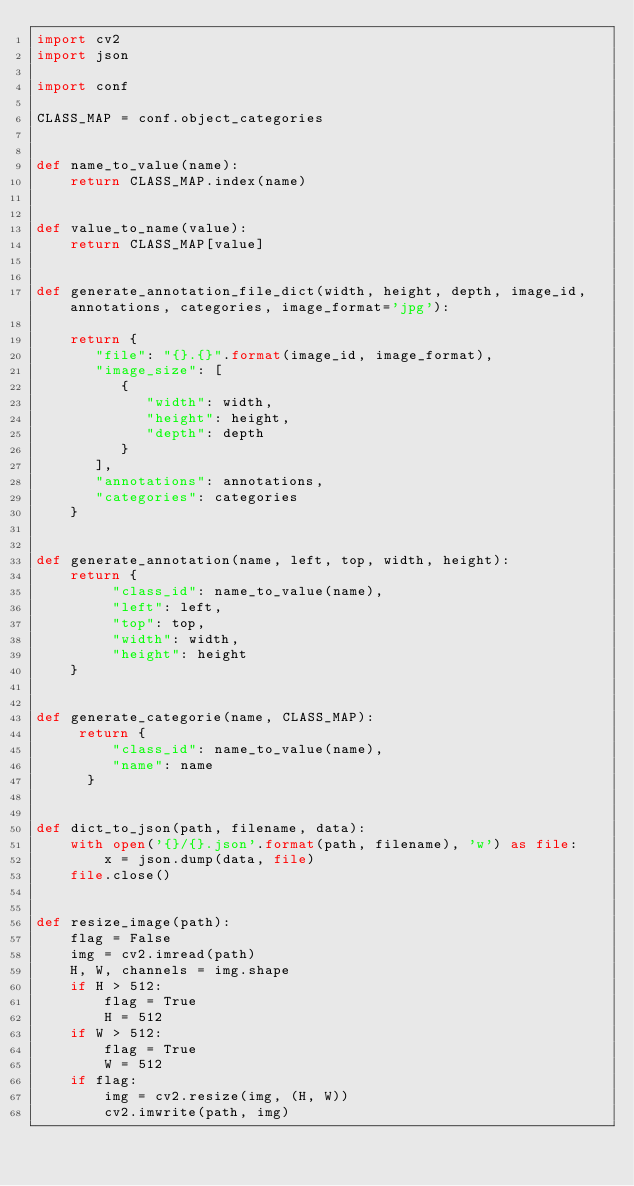Convert code to text. <code><loc_0><loc_0><loc_500><loc_500><_Python_>import cv2
import json

import conf

CLASS_MAP = conf.object_categories


def name_to_value(name):
    return CLASS_MAP.index(name)


def value_to_name(value):
    return CLASS_MAP[value]


def generate_annotation_file_dict(width, height, depth, image_id, annotations, categories, image_format='jpg'):
    
    return {
       "file": "{}.{}".format(image_id, image_format),
       "image_size": [
          {
             "width": width,
             "height": height,
             "depth": depth
          }
       ],
       "annotations": annotations,
       "categories": categories
    }


def generate_annotation(name, left, top, width, height):
    return {
         "class_id": name_to_value(name),
         "left": left,
         "top": top,
         "width": width,
         "height": height
    }


def generate_categorie(name, CLASS_MAP):
     return {
         "class_id": name_to_value(name),
         "name": name
      }

    
def dict_to_json(path, filename, data):
    with open('{}/{}.json'.format(path, filename), 'w') as file:
        x = json.dump(data, file)
    file.close()

    
def resize_image(path):
    flag = False
    img = cv2.imread(path)
    H, W, channels = img.shape
    if H > 512:
        flag = True
        H = 512
    if W > 512:
        flag = True
        W = 512
    if flag:
        img = cv2.resize(img, (H, W))
        cv2.imwrite(path, img)</code> 